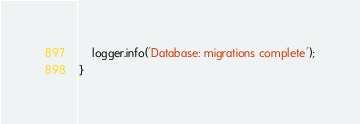Convert code to text. <code><loc_0><loc_0><loc_500><loc_500><_TypeScript_>    logger.info('Database: migrations complete');
}
</code> 